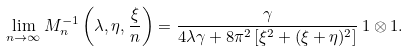Convert formula to latex. <formula><loc_0><loc_0><loc_500><loc_500>\lim _ { n \to \infty } { M } ^ { - 1 } _ { n } \left ( \lambda , \eta , \frac { \xi } { n } \right ) = \frac { \gamma } { 4 \lambda \gamma + 8 { \pi ^ { 2 } } \left [ \xi ^ { 2 } + ( \xi + \eta ) ^ { 2 } \right ] } \, { 1 } \otimes { 1 } .</formula> 